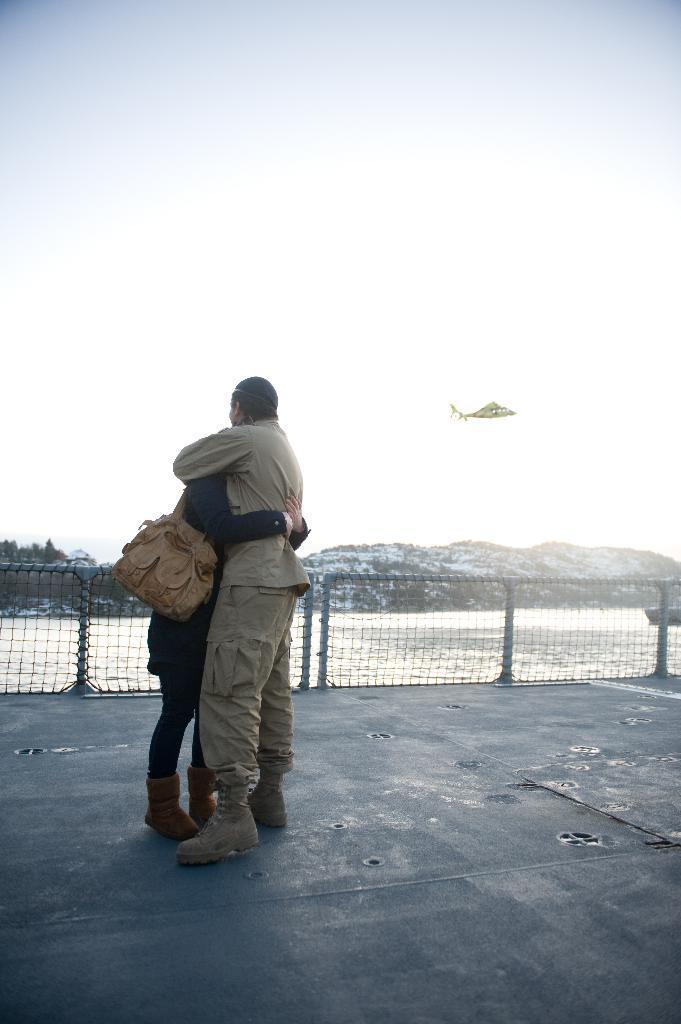Can you describe this image briefly? In this picture we can see two people standing on the floor, fencing net, water, trees, mountains and in the background we can see a helicopter flying in the sky. 